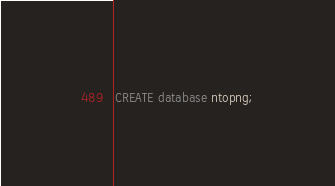Convert code to text. <code><loc_0><loc_0><loc_500><loc_500><_SQL_>CREATE database ntopng;
</code> 